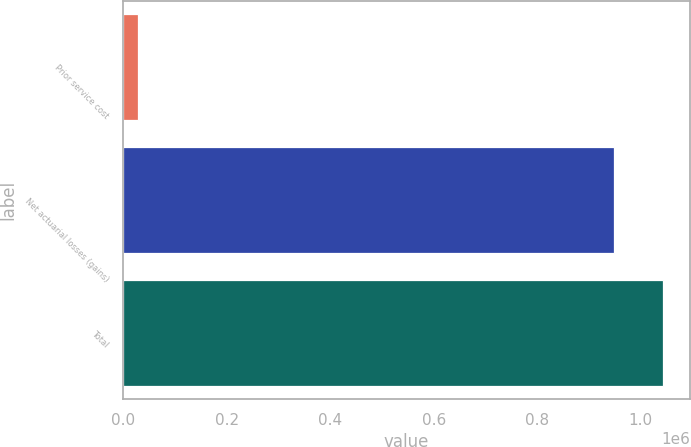Convert chart. <chart><loc_0><loc_0><loc_500><loc_500><bar_chart><fcel>Prior service cost<fcel>Net actuarial losses (gains)<fcel>Total<nl><fcel>27895<fcel>948389<fcel>1.04323e+06<nl></chart> 